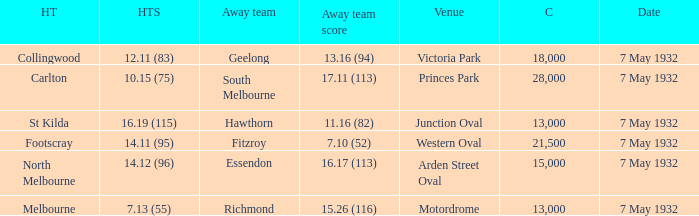Which home team has a Away team of hawthorn? St Kilda. 